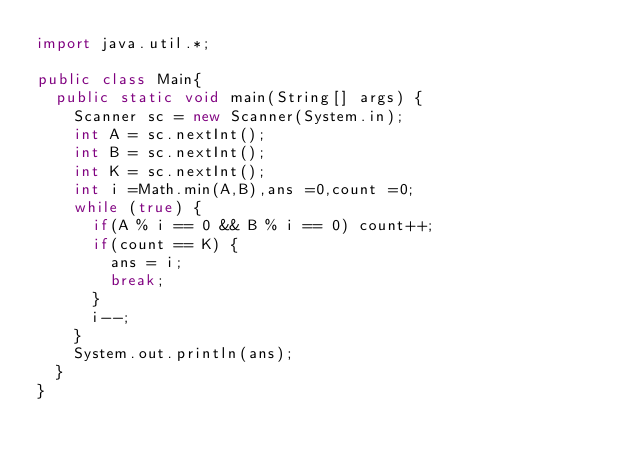Convert code to text. <code><loc_0><loc_0><loc_500><loc_500><_Java_>import java.util.*;

public class Main{
  public static void main(String[] args) {
    Scanner sc = new Scanner(System.in);
    int A = sc.nextInt();
    int B = sc.nextInt();
    int K = sc.nextInt();
    int i =Math.min(A,B),ans =0,count =0;
    while (true) {
      if(A % i == 0 && B % i == 0) count++;
      if(count == K) {
        ans = i;
        break;
      }
      i--;
    }
    System.out.println(ans);
  }
}</code> 